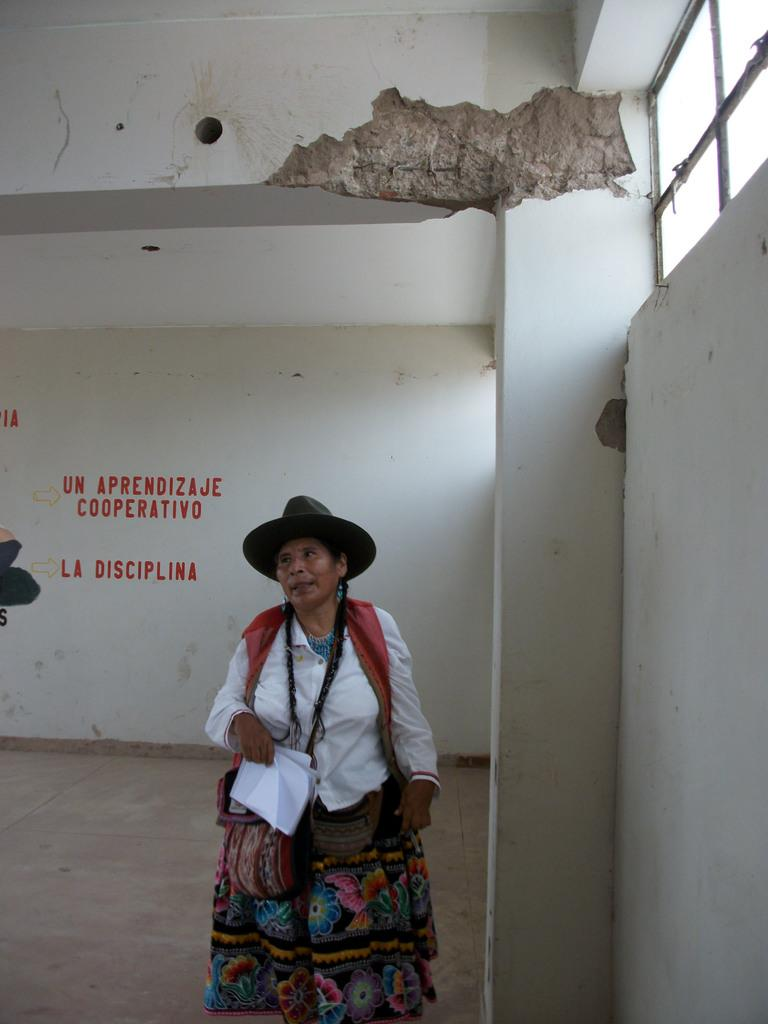Who is the main subject in the image? There is a woman in the image. What is the woman wearing? The woman is wearing a costume and a hat. What is the woman carrying? The woman is carrying bags and holding a book in her hands. What is the woman standing on? The woman is standing on the floor. What other objects can be seen in the image? There is a ventilator and text on the wall in the image. What type of tent can be seen in the image? There is no tent present in the image. What caused the earthquake in the image? There is no earthquake mentioned or depicted in the image. 